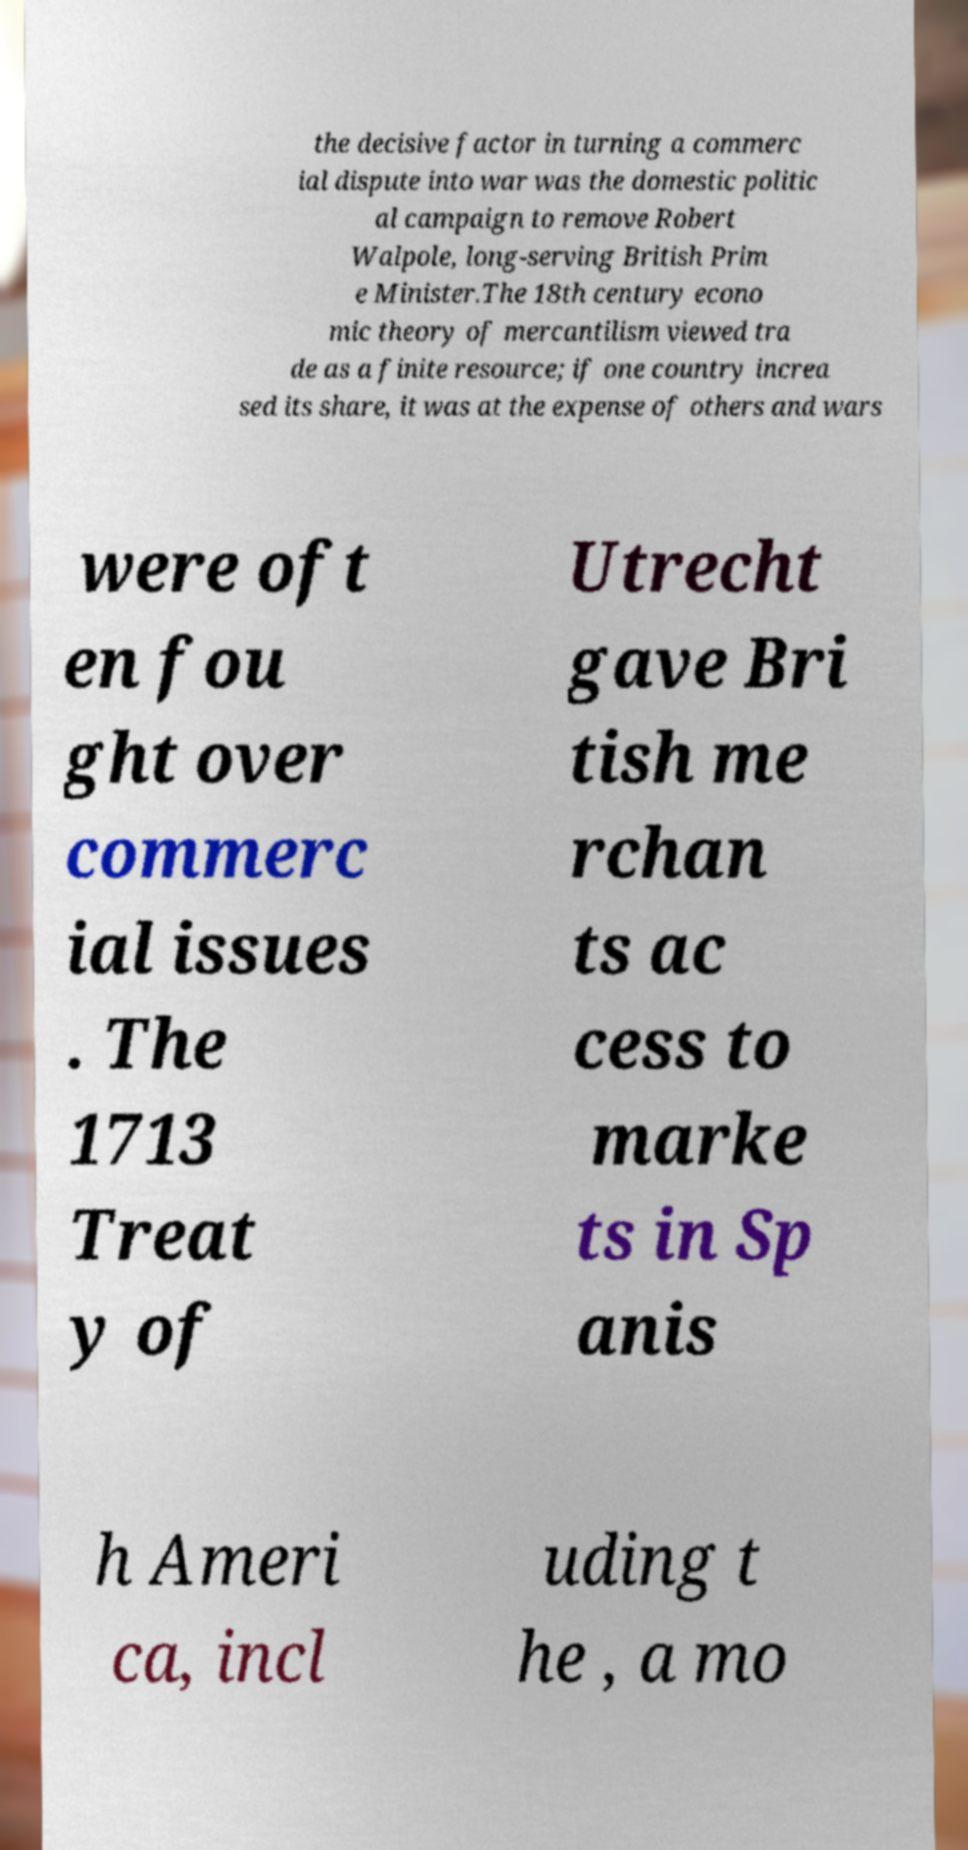What messages or text are displayed in this image? I need them in a readable, typed format. the decisive factor in turning a commerc ial dispute into war was the domestic politic al campaign to remove Robert Walpole, long-serving British Prim e Minister.The 18th century econo mic theory of mercantilism viewed tra de as a finite resource; if one country increa sed its share, it was at the expense of others and wars were oft en fou ght over commerc ial issues . The 1713 Treat y of Utrecht gave Bri tish me rchan ts ac cess to marke ts in Sp anis h Ameri ca, incl uding t he , a mo 